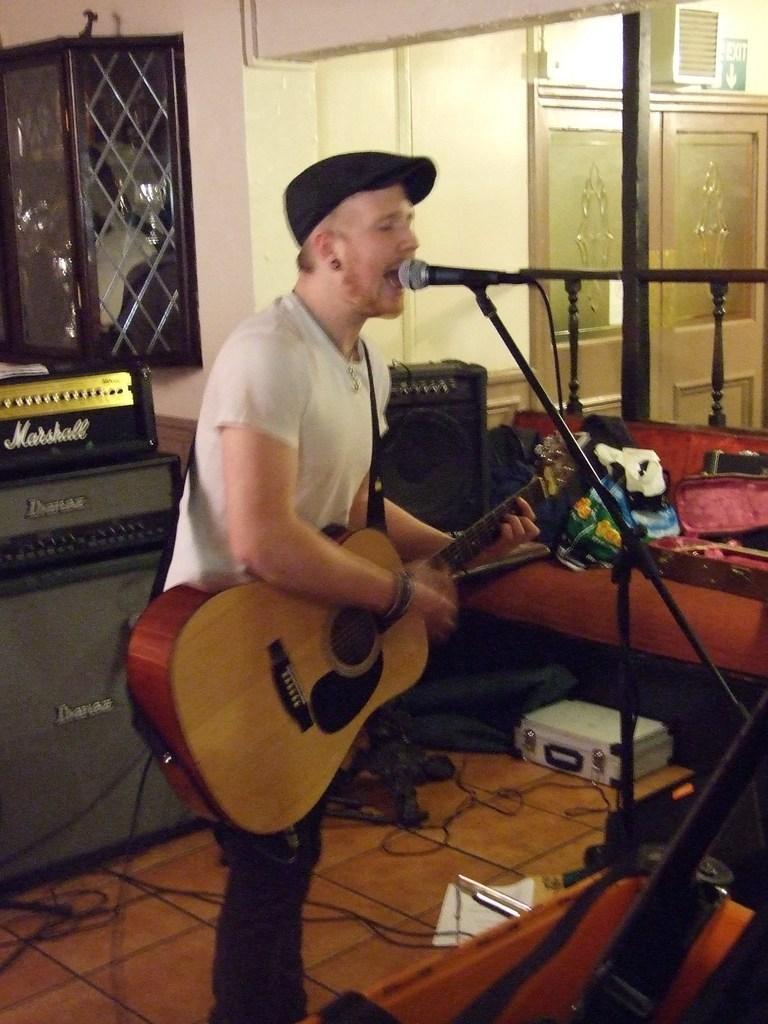Can you describe this image briefly? Here we can see a person playing a guitar and singing a song with a microphone in front of her and around him we can see some other musical instruments present 